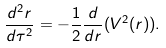Convert formula to latex. <formula><loc_0><loc_0><loc_500><loc_500>\frac { d ^ { 2 } r } { d \tau ^ { 2 } } = - \frac { 1 } { 2 } \frac { d } { d r } ( V ^ { 2 } ( r ) ) .</formula> 